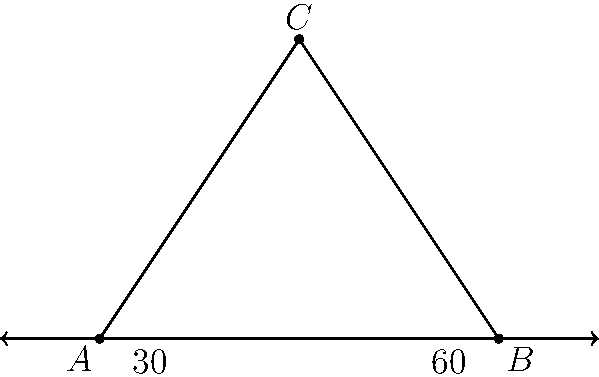In analyzing the roof structure of a historical cathedral, you encounter a triangular gable with the following properties: the base angles measure 30° and 60°, respectively. What is the measure of the apex angle at the top of the gable? Consider how this angle might reflect architectural styles and engineering capabilities of the time. Let's approach this step-by-step, considering the historical and architectural implications:

1) First, recall the fundamental property of triangles: the sum of all angles in a triangle is always 180°.

2) We're given two base angles: 30° and 60°. Let's call the apex angle $x$.

3) We can set up an equation:
   $30° + 60° + x = 180°$

4) Simplify:
   $90° + x = 180°$

5) Solve for $x$:
   $x = 180° - 90° = 90°$

6) Historical and architectural considerations:
   - A 90° apex angle creates an isosceles right triangle, which was a common and structurally sound shape in many historical buildings.
   - This shape allowed for efficient water drainage and snow shedding, crucial in many climates.
   - The 30°-60°-90° triangle is a "special" right triangle, often used in classical and medieval architecture for its pleasing proportions and ease of construction.
   - This angle combination might suggest influence from Gothic architecture, where equilateral triangles (60°-60°-60°) were common, but adapted for practical reasons.

7) The name "gable" itself has rich etymological roots, tracing back to Old English and Germanic languages, reflecting the long history of this architectural element.
Answer: 90° 